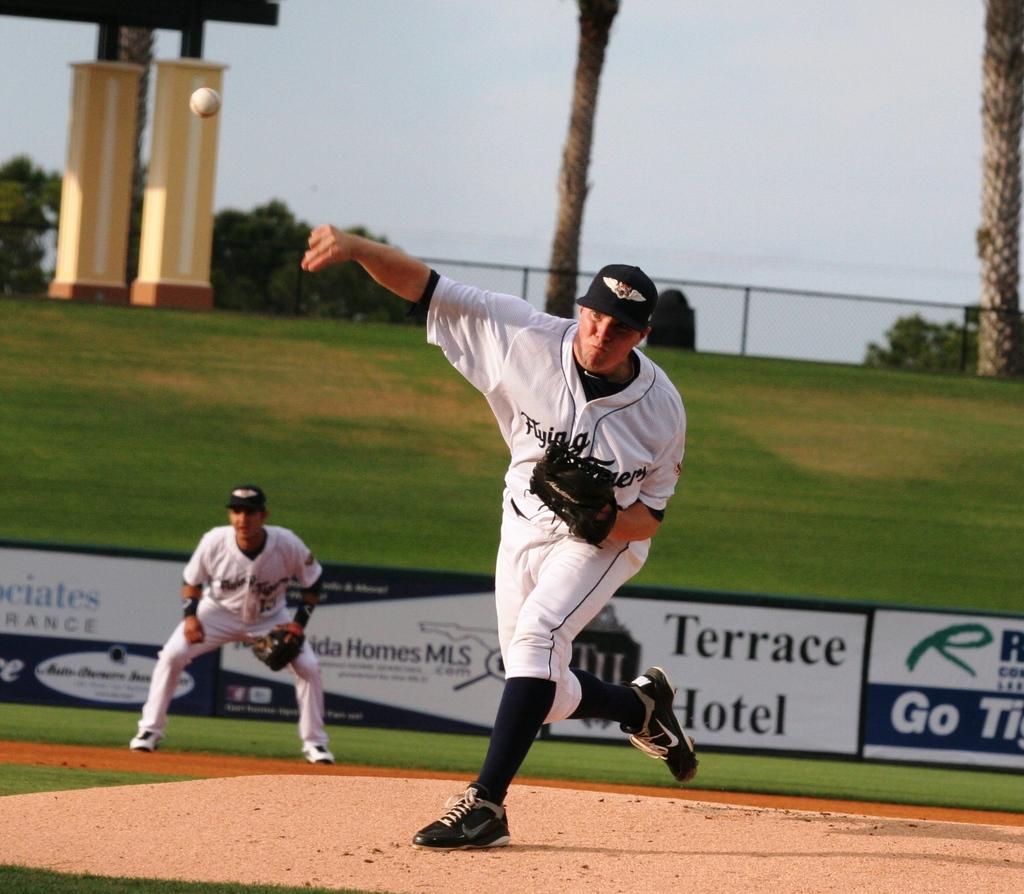What does the pitcher's jersey say?
Provide a short and direct response. Flying. What hotel is advertised on the sign?
Offer a very short reply. Terrace hotel. 